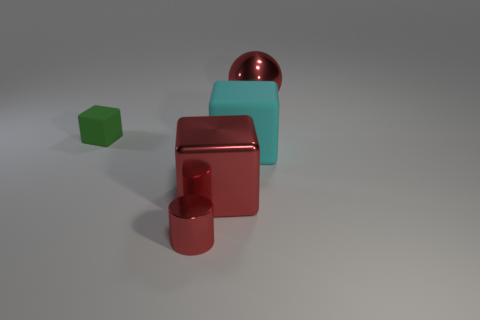Subtract all large cubes. How many cubes are left? 1 Add 5 tiny red shiny cubes. How many objects exist? 10 Subtract all cyan cubes. How many cubes are left? 2 Subtract 1 green cubes. How many objects are left? 4 Subtract all cylinders. How many objects are left? 4 Subtract 1 blocks. How many blocks are left? 2 Subtract all green blocks. Subtract all red cylinders. How many blocks are left? 2 Subtract all cyan cylinders. How many cyan blocks are left? 1 Subtract all small cylinders. Subtract all tiny blue shiny spheres. How many objects are left? 4 Add 1 cyan rubber cubes. How many cyan rubber cubes are left? 2 